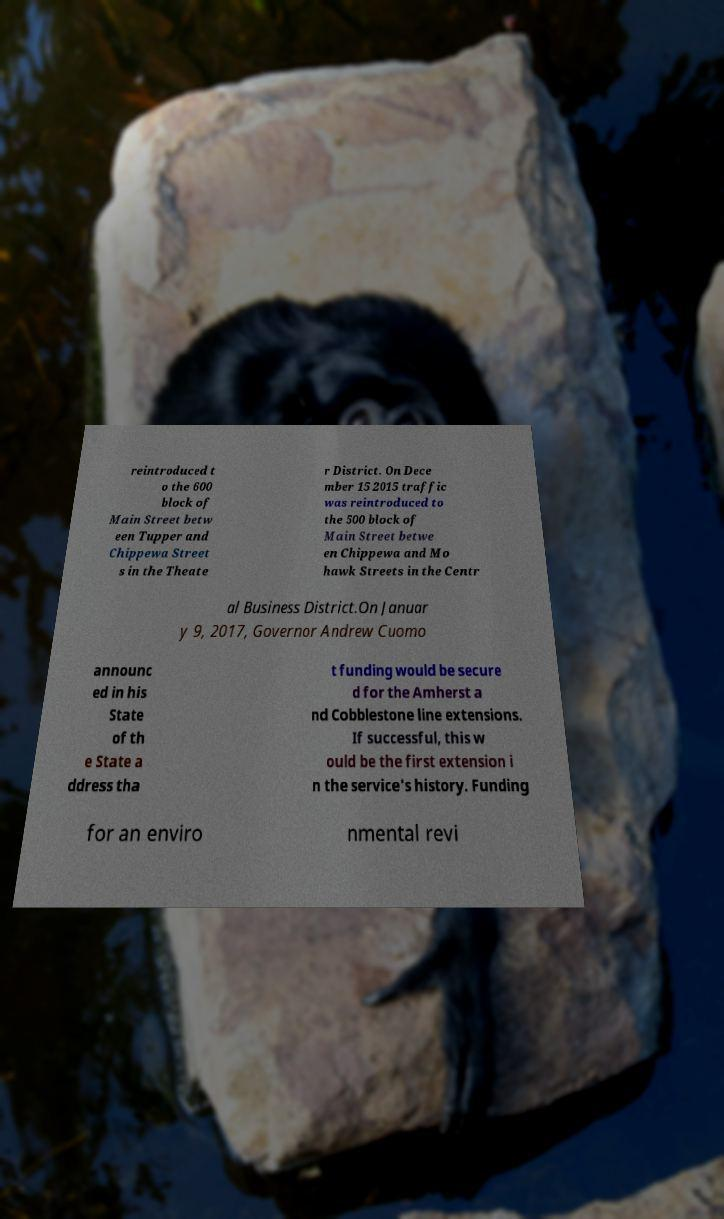There's text embedded in this image that I need extracted. Can you transcribe it verbatim? reintroduced t o the 600 block of Main Street betw een Tupper and Chippewa Street s in the Theate r District. On Dece mber 15 2015 traffic was reintroduced to the 500 block of Main Street betwe en Chippewa and Mo hawk Streets in the Centr al Business District.On Januar y 9, 2017, Governor Andrew Cuomo announc ed in his State of th e State a ddress tha t funding would be secure d for the Amherst a nd Cobblestone line extensions. If successful, this w ould be the first extension i n the service's history. Funding for an enviro nmental revi 